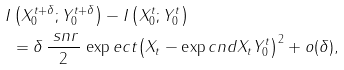<formula> <loc_0><loc_0><loc_500><loc_500>I & \left ( X _ { 0 } ^ { t + \delta } ; Y _ { 0 } ^ { t + \delta } \right ) - I \left ( X _ { 0 } ^ { t } ; Y _ { 0 } ^ { t } \right ) \\ & = \delta \, \frac { \ s n r } { 2 } \, \exp e c t { \left ( X _ { t } - \exp c n d { X _ { t } } { Y _ { 0 } ^ { t } } \right ) ^ { 2 } } + o ( \delta ) ,</formula> 